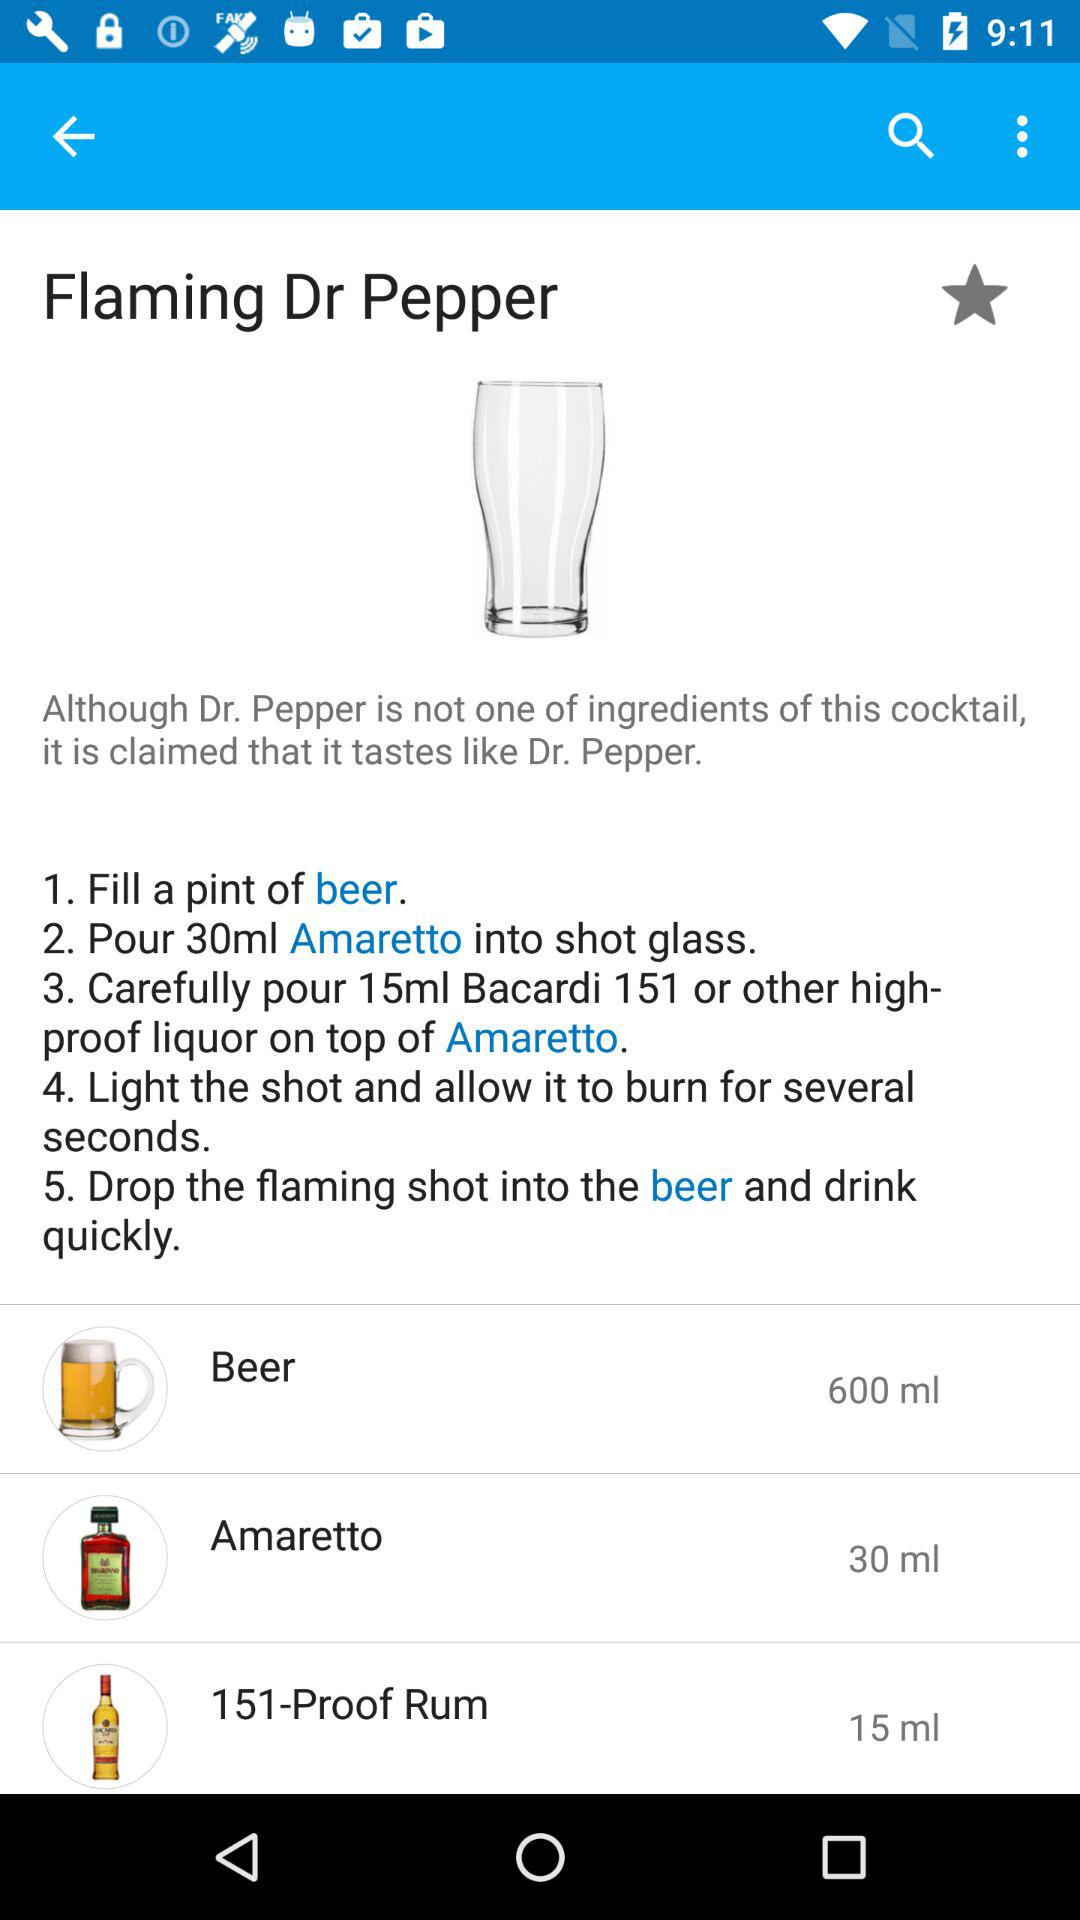What is the quantity of 151-Proof Rum? The quantity is 15 ml. 